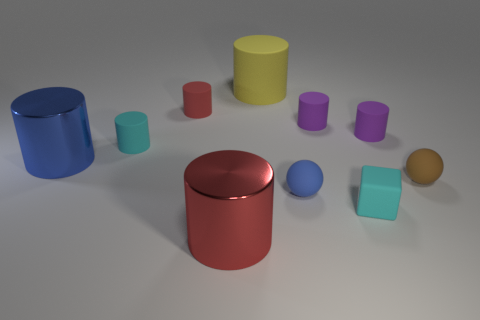What material is the large yellow object behind the large metallic object that is behind the small brown ball?
Provide a succinct answer. Rubber. What is the shape of the blue thing that is made of the same material as the tiny red object?
Offer a terse response. Sphere. Is there any other thing that is the same shape as the yellow object?
Provide a succinct answer. Yes. There is a yellow matte thing; how many red matte cylinders are on the right side of it?
Offer a terse response. 0. Are any big purple shiny blocks visible?
Offer a terse response. No. What color is the object that is to the left of the cyan object that is left of the small ball on the left side of the brown matte ball?
Keep it short and to the point. Blue. Is there a large red metal thing in front of the small brown matte thing on the right side of the yellow rubber cylinder?
Your response must be concise. Yes. Do the shiny cylinder that is left of the small red cylinder and the metallic cylinder in front of the tiny brown ball have the same color?
Offer a terse response. No. How many shiny spheres are the same size as the blue shiny thing?
Your response must be concise. 0. There is a cyan matte thing that is to the left of the red rubber cylinder; is it the same size as the big rubber object?
Your response must be concise. No. 